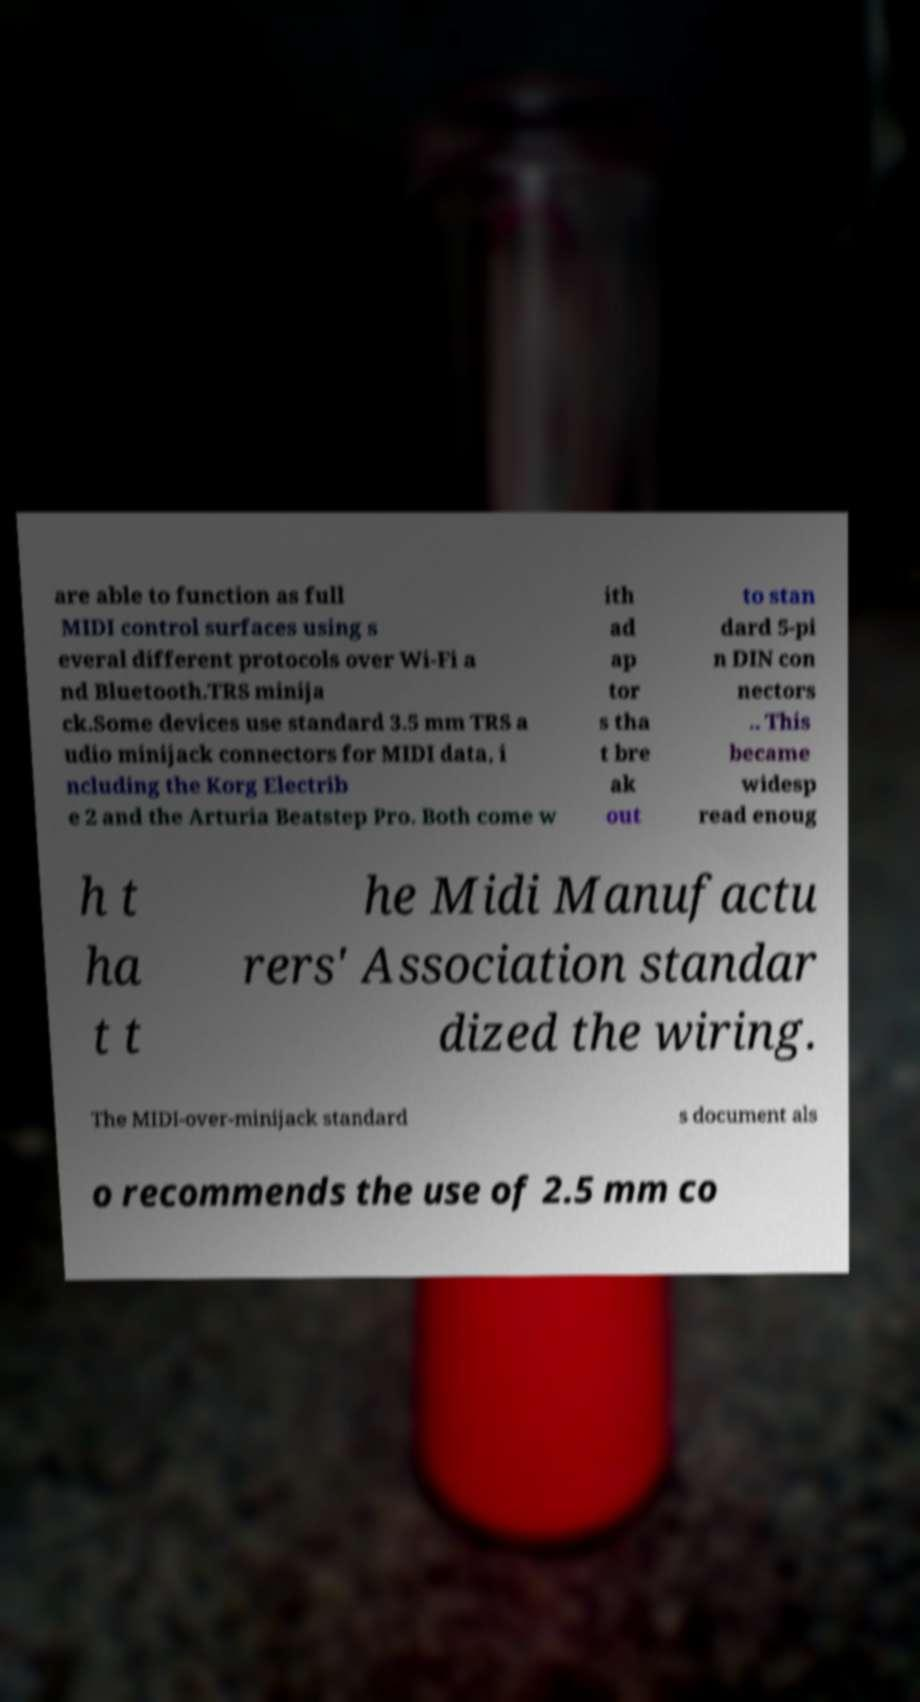Can you accurately transcribe the text from the provided image for me? are able to function as full MIDI control surfaces using s everal different protocols over Wi-Fi a nd Bluetooth.TRS minija ck.Some devices use standard 3.5 mm TRS a udio minijack connectors for MIDI data, i ncluding the Korg Electrib e 2 and the Arturia Beatstep Pro. Both come w ith ad ap tor s tha t bre ak out to stan dard 5-pi n DIN con nectors .. This became widesp read enoug h t ha t t he Midi Manufactu rers' Association standar dized the wiring. The MIDI-over-minijack standard s document als o recommends the use of 2.5 mm co 